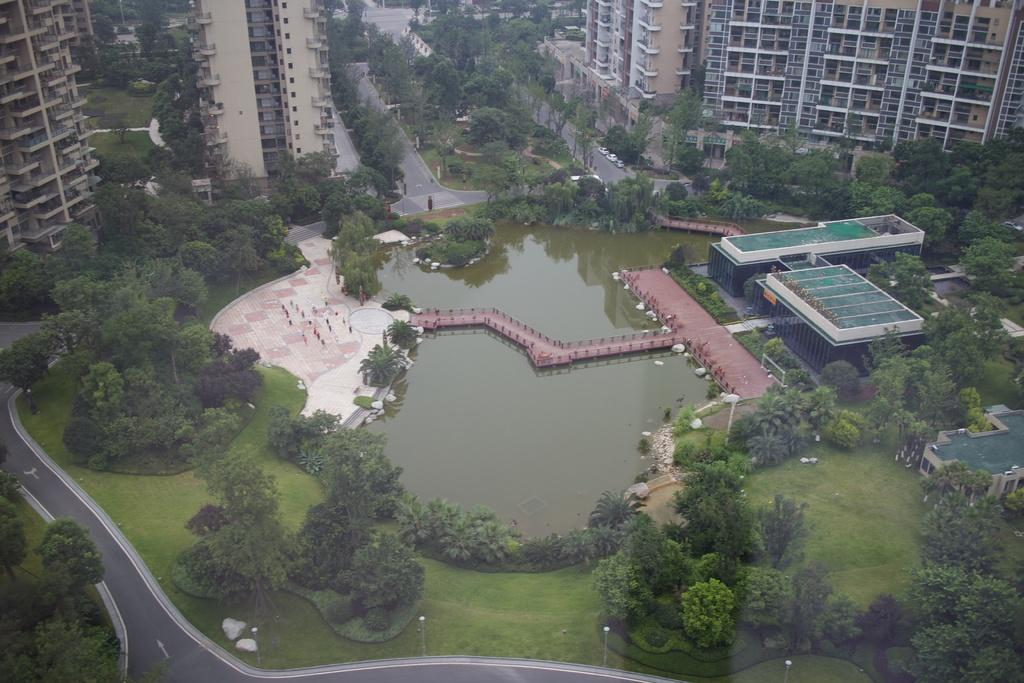What type of structures can be seen in the image? There are many buildings in the image. What natural elements are present in the image? There are trees, grass, and water visible in the image. What type of surface can be used for walking or driving in the image? There is a path and a road in the image. What are the poles used for in the image? The purpose of the poles in the image is not specified, but they could be for lighting, signage, or other purposes. Can you tell me how much knowledge the man in the image has about the buildings? There is no man present in the image, so it is not possible to determine how much knowledge he has about the buildings. 